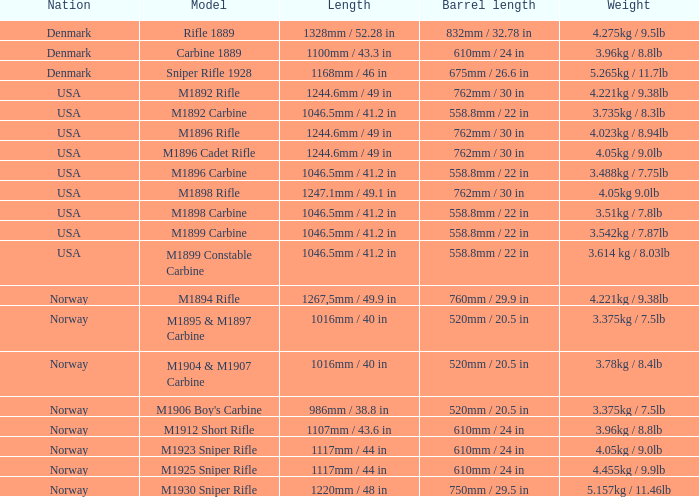What is the distance, when the barrel's extent is 750mm / 2 1220mm / 48 in. 